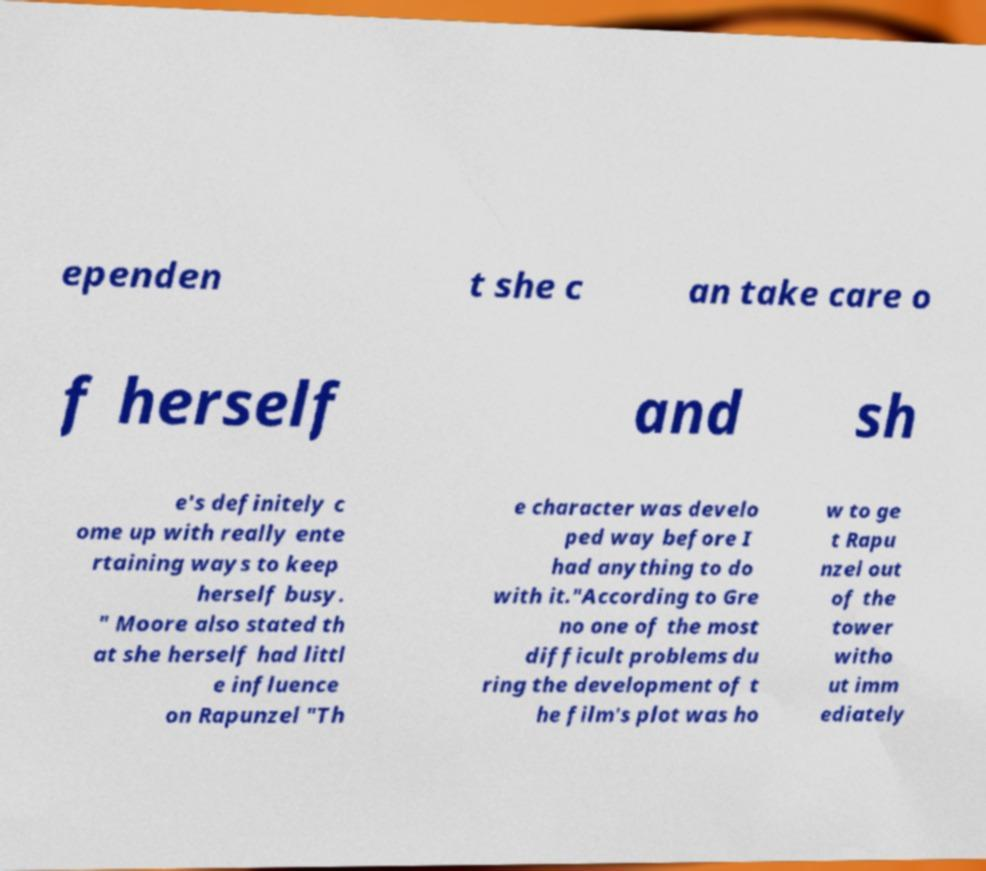I need the written content from this picture converted into text. Can you do that? ependen t she c an take care o f herself and sh e's definitely c ome up with really ente rtaining ways to keep herself busy. " Moore also stated th at she herself had littl e influence on Rapunzel "Th e character was develo ped way before I had anything to do with it."According to Gre no one of the most difficult problems du ring the development of t he film's plot was ho w to ge t Rapu nzel out of the tower witho ut imm ediately 